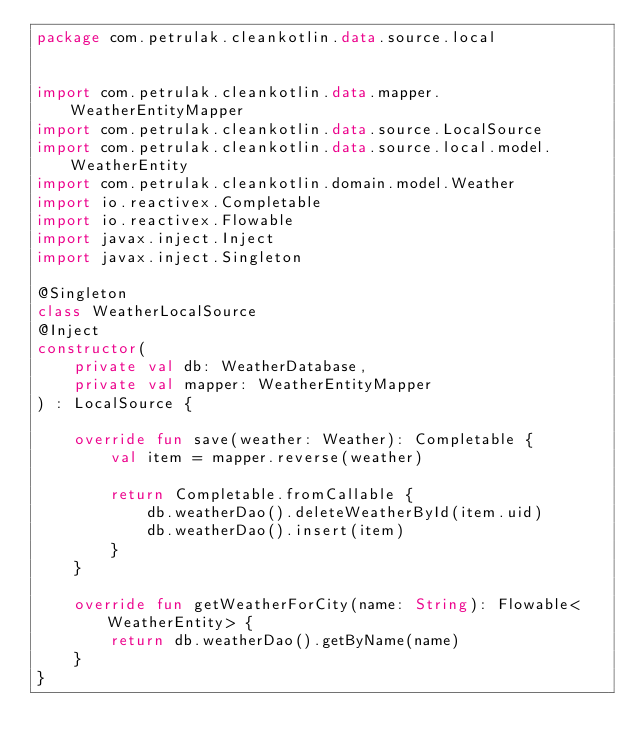Convert code to text. <code><loc_0><loc_0><loc_500><loc_500><_Kotlin_>package com.petrulak.cleankotlin.data.source.local


import com.petrulak.cleankotlin.data.mapper.WeatherEntityMapper
import com.petrulak.cleankotlin.data.source.LocalSource
import com.petrulak.cleankotlin.data.source.local.model.WeatherEntity
import com.petrulak.cleankotlin.domain.model.Weather
import io.reactivex.Completable
import io.reactivex.Flowable
import javax.inject.Inject
import javax.inject.Singleton

@Singleton
class WeatherLocalSource
@Inject
constructor(
    private val db: WeatherDatabase,
    private val mapper: WeatherEntityMapper
) : LocalSource {

    override fun save(weather: Weather): Completable {
        val item = mapper.reverse(weather)

        return Completable.fromCallable {
            db.weatherDao().deleteWeatherById(item.uid)
            db.weatherDao().insert(item)
        }
    }

    override fun getWeatherForCity(name: String): Flowable<WeatherEntity> {
        return db.weatherDao().getByName(name)
    }
}
</code> 